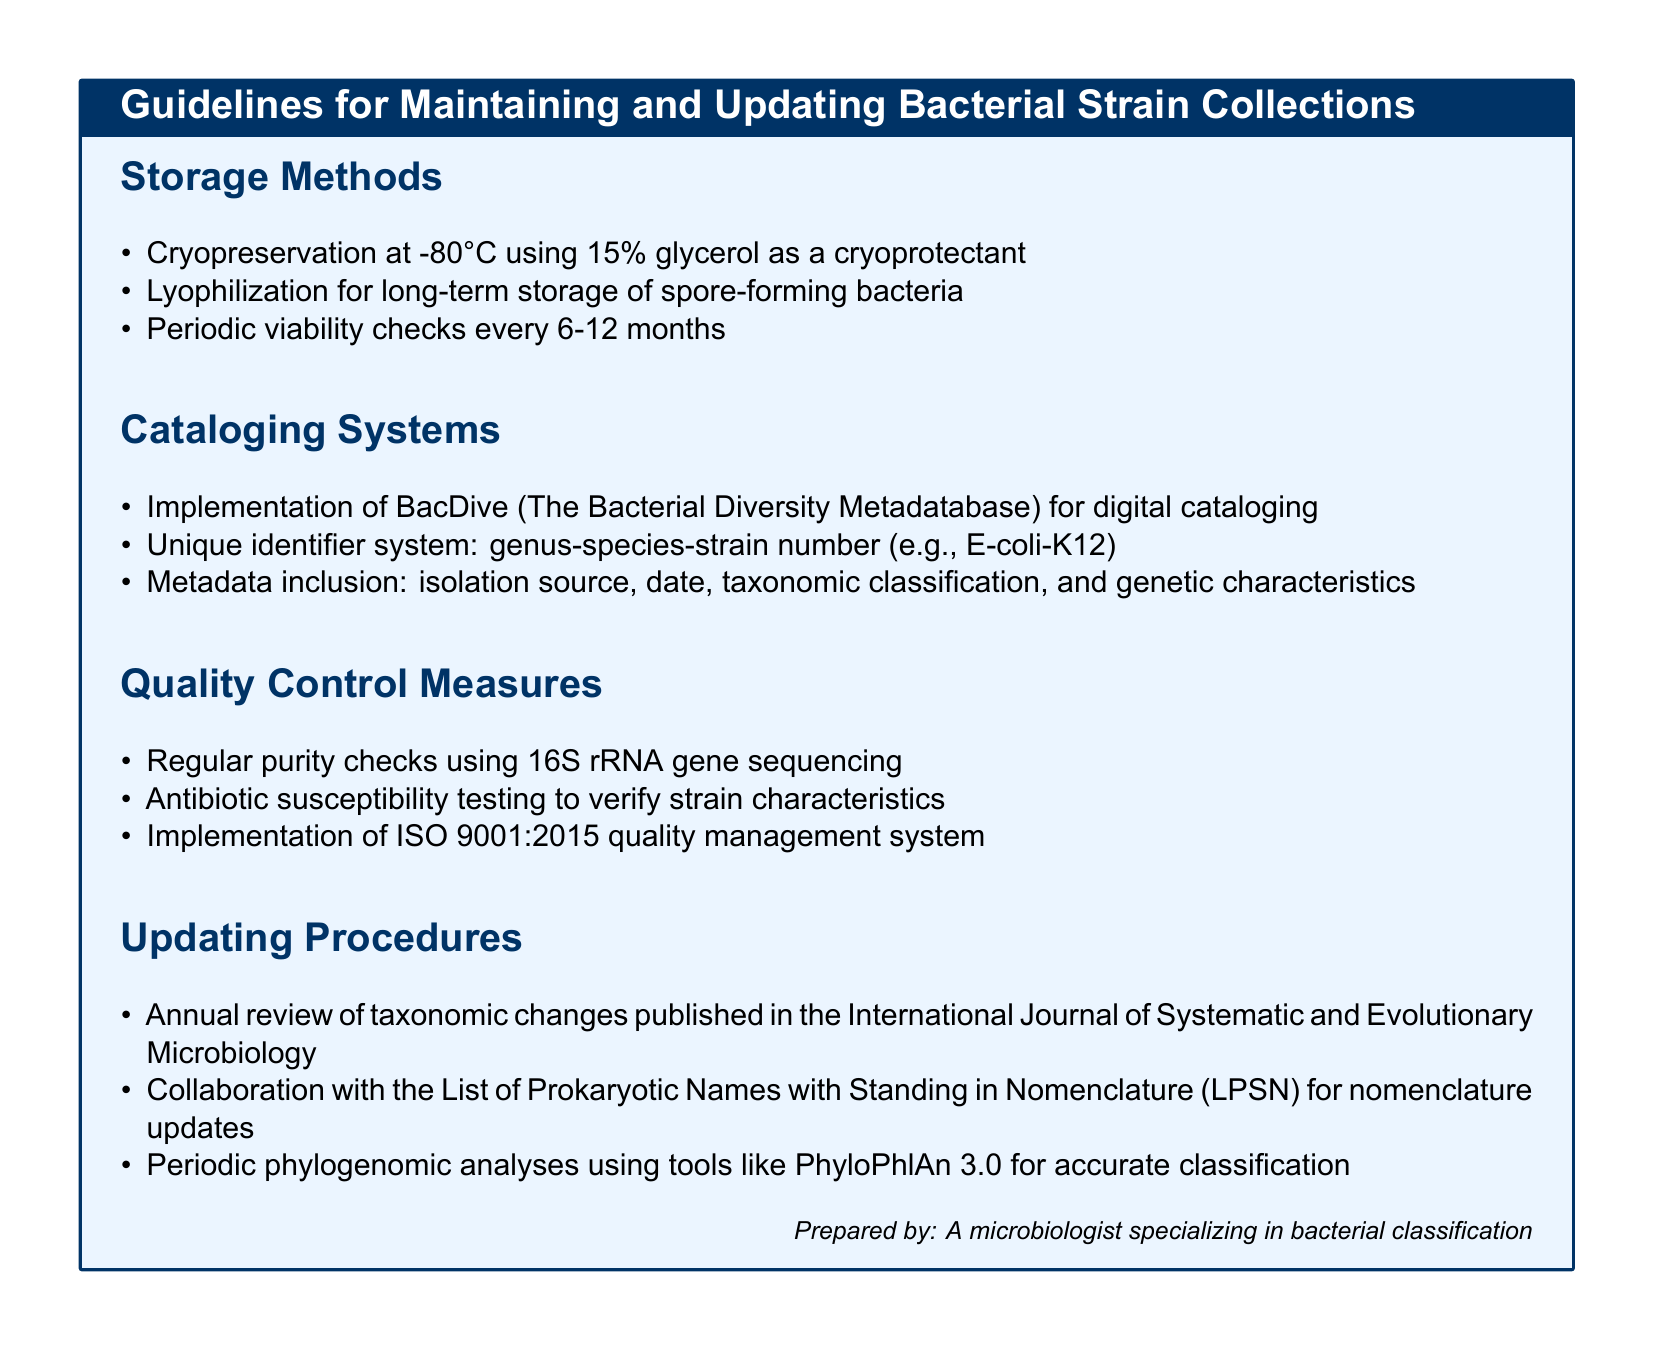What are the storage methods recommended for bacterial strains? The document outlines specific storage methods, including cryopreservation, lyophilization, and periodic viability checks.
Answer: Cryopreservation, Lyophilization What is the cryoprotectant used in cryopreservation? The document mentions glycerol as a cryoprotectant for cryopreservation.
Answer: Glycerol How often should periodic viability checks be conducted? The document specifies the frequency for conducting viability checks of bacterial strains.
Answer: Every 6-12 months What digital cataloging system is suggested? The guidelines recommend a specific digital cataloging system for bacterial strain collections.
Answer: BacDive Which quality control measure involves the 16S rRNA gene? The document describes a quality control measure employing gene sequencing for purity checks.
Answer: Regular purity checks What formal quality management system is implemented? The document indicates a specific quality management system followed in maintaining bacterial strain collections.
Answer: ISO 9001:2015 What is the frequency of the review for taxonomic changes? The document states how often taxonomic changes should be reviewed according to published resources.
Answer: Annual Which publication is referred to for taxonomic changes? The document cites a specific journal for updates on taxonomic classifications.
Answer: International Journal of Systematic and Evolutionary Microbiology What type of analyses is suggested for updating bacterial classifications? The document mentions a specific approach for accurate classification based on genomic data.
Answer: Phylogenomic analyses 